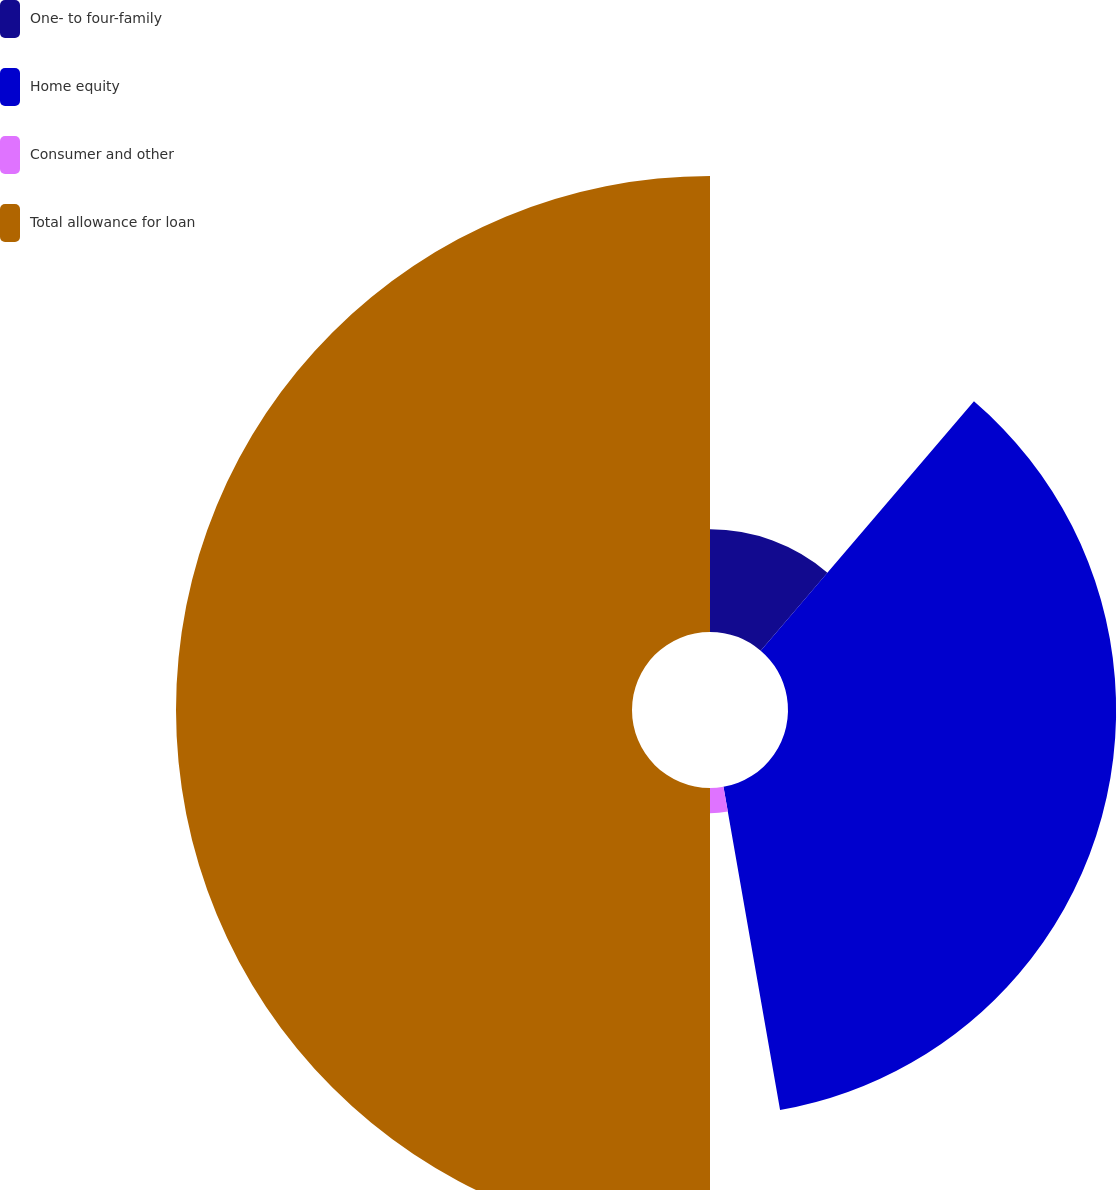Convert chart to OTSL. <chart><loc_0><loc_0><loc_500><loc_500><pie_chart><fcel>One- to four-family<fcel>Home equity<fcel>Consumer and other<fcel>Total allowance for loan<nl><fcel>11.26%<fcel>35.98%<fcel>2.76%<fcel>50.0%<nl></chart> 